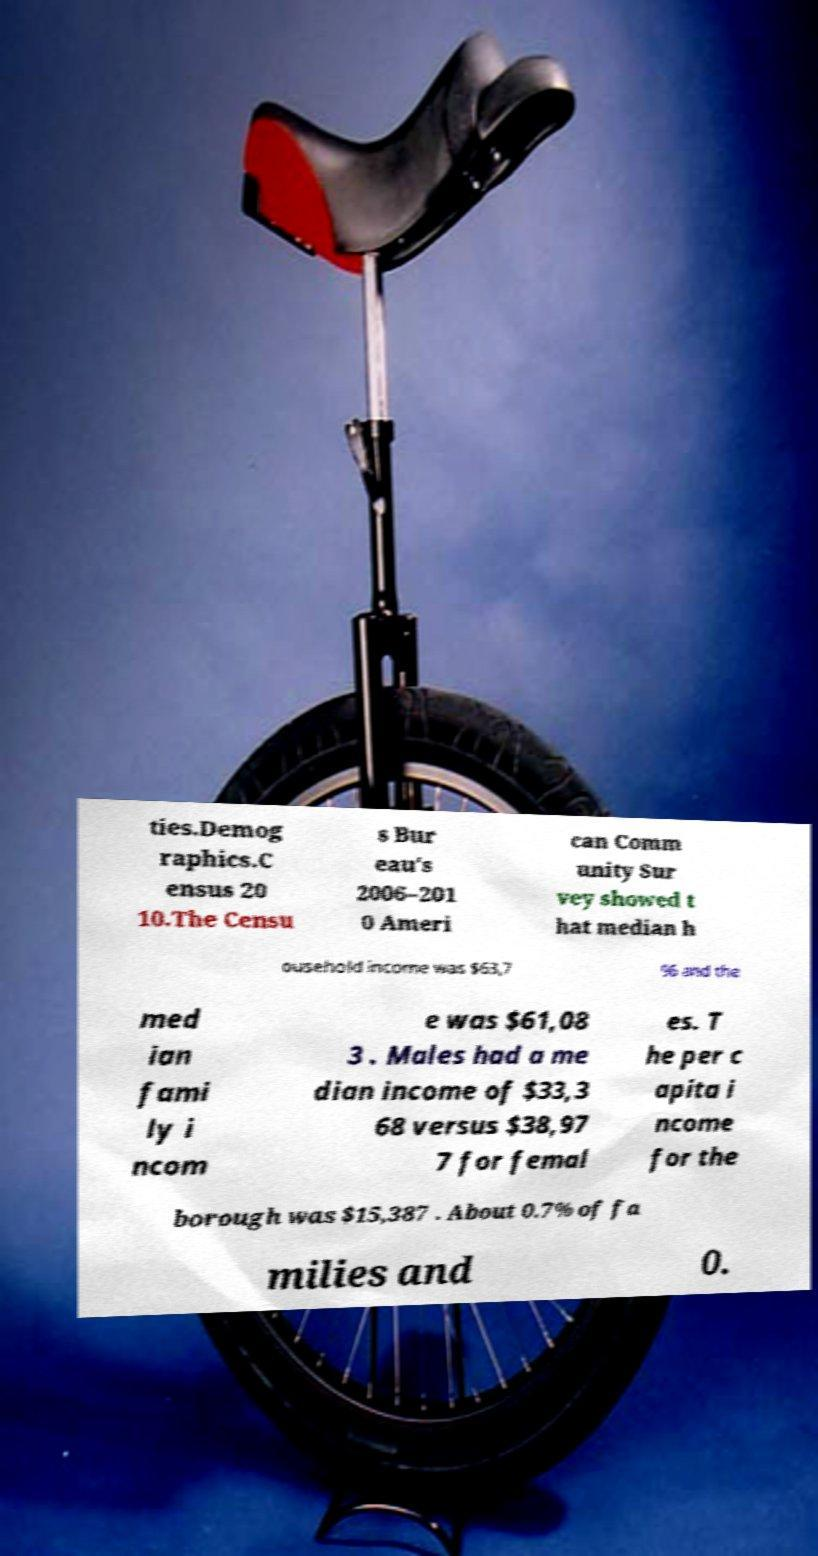I need the written content from this picture converted into text. Can you do that? ties.Demog raphics.C ensus 20 10.The Censu s Bur eau's 2006–201 0 Ameri can Comm unity Sur vey showed t hat median h ousehold income was $63,7 96 and the med ian fami ly i ncom e was $61,08 3 . Males had a me dian income of $33,3 68 versus $38,97 7 for femal es. T he per c apita i ncome for the borough was $15,387 . About 0.7% of fa milies and 0. 